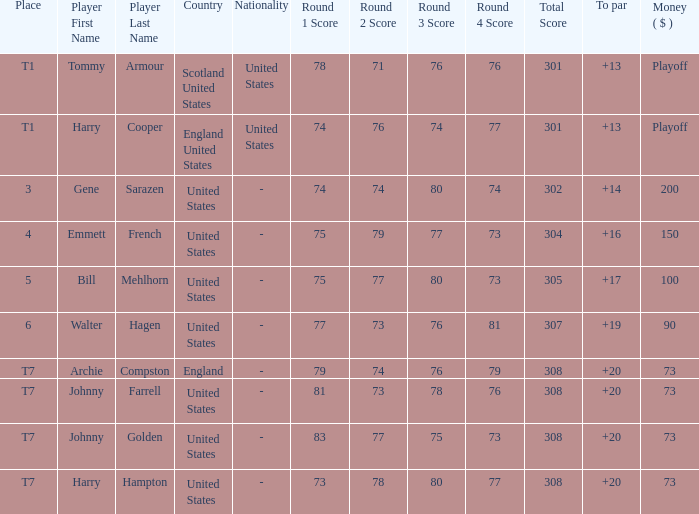What is the ranking for the United States when the money is $200? 3.0. 